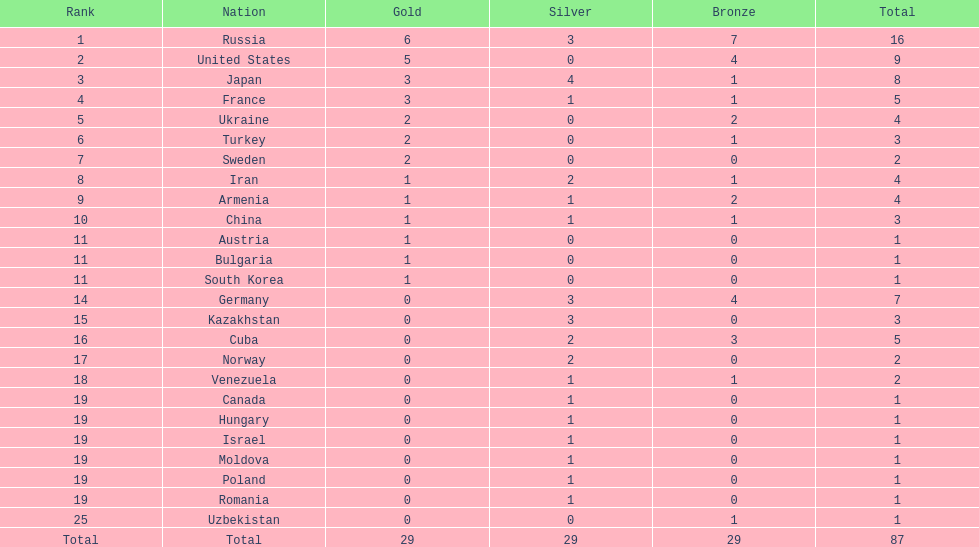Which country won only one medal, a bronze medal? Uzbekistan. 